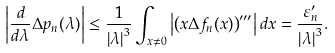<formula> <loc_0><loc_0><loc_500><loc_500>\left | \frac { d } { d \lambda } \Delta p _ { n } ( \lambda ) \right | \leq \frac { 1 } { \left | \lambda \right | ^ { 3 } } \int _ { x \neq 0 } \left | \left ( x \Delta f _ { n } ( x ) \right ) ^ { \prime \prime \prime } \right | d x = \frac { \varepsilon _ { n } ^ { \prime } } { \left | \lambda \right | ^ { 3 } } .</formula> 